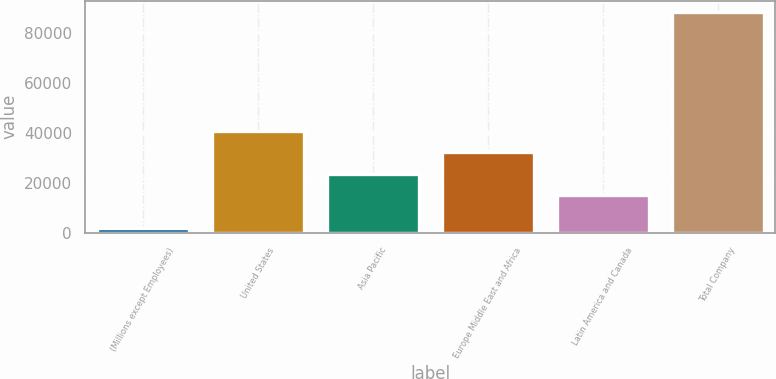Convert chart to OTSL. <chart><loc_0><loc_0><loc_500><loc_500><bar_chart><fcel>(Millions except Employees)<fcel>United States<fcel>Asia Pacific<fcel>Europe Middle East and Africa<fcel>Latin America and Canada<fcel>Total Company<nl><fcel>2013<fcel>41023.2<fcel>23692.4<fcel>32357.8<fcel>15027<fcel>88667<nl></chart> 